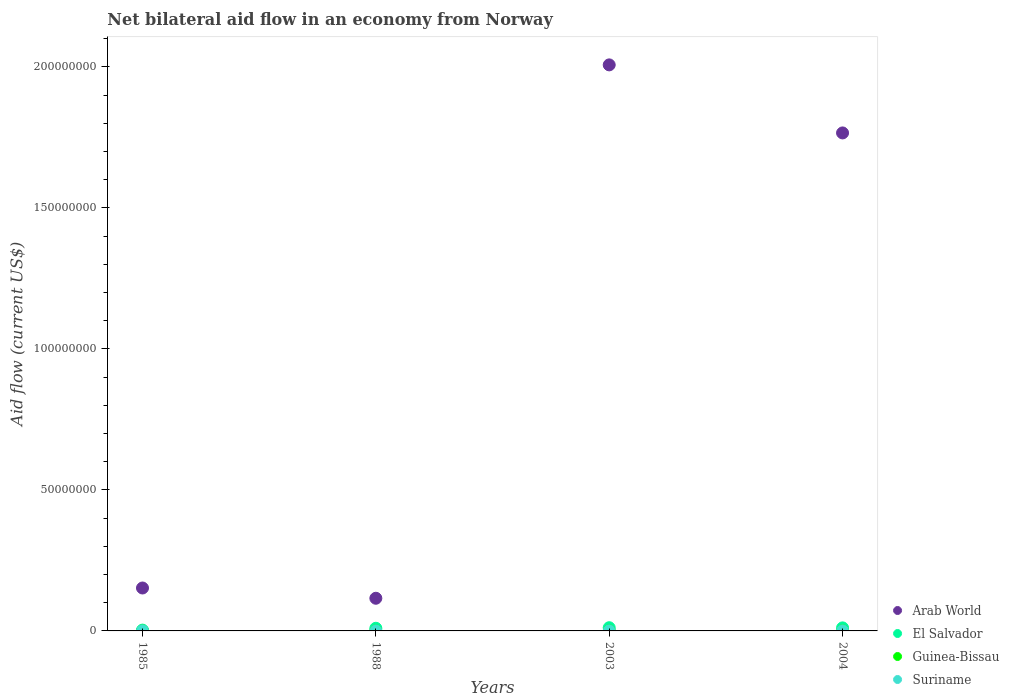What is the net bilateral aid flow in El Salvador in 2004?
Ensure brevity in your answer.  1.08e+06. Across all years, what is the maximum net bilateral aid flow in El Salvador?
Offer a terse response. 1.14e+06. Across all years, what is the minimum net bilateral aid flow in Suriname?
Offer a very short reply. 10000. What is the difference between the net bilateral aid flow in Guinea-Bissau in 1988 and the net bilateral aid flow in El Salvador in 2003?
Provide a short and direct response. -1.13e+06. What is the average net bilateral aid flow in Guinea-Bissau per year?
Your answer should be compact. 3.25e+04. In the year 1988, what is the difference between the net bilateral aid flow in Guinea-Bissau and net bilateral aid flow in El Salvador?
Provide a short and direct response. -9.30e+05. What is the ratio of the net bilateral aid flow in Guinea-Bissau in 1985 to that in 2004?
Offer a very short reply. 0.17. Is the difference between the net bilateral aid flow in Guinea-Bissau in 1985 and 2003 greater than the difference between the net bilateral aid flow in El Salvador in 1985 and 2003?
Offer a terse response. Yes. In how many years, is the net bilateral aid flow in Guinea-Bissau greater than the average net bilateral aid flow in Guinea-Bissau taken over all years?
Provide a succinct answer. 2. Is it the case that in every year, the sum of the net bilateral aid flow in Guinea-Bissau and net bilateral aid flow in El Salvador  is greater than the sum of net bilateral aid flow in Arab World and net bilateral aid flow in Suriname?
Provide a short and direct response. No. Does the net bilateral aid flow in Arab World monotonically increase over the years?
Keep it short and to the point. No. Is the net bilateral aid flow in Arab World strictly greater than the net bilateral aid flow in Suriname over the years?
Your answer should be very brief. Yes. Is the net bilateral aid flow in Guinea-Bissau strictly less than the net bilateral aid flow in Arab World over the years?
Your answer should be compact. Yes. Are the values on the major ticks of Y-axis written in scientific E-notation?
Ensure brevity in your answer.  No. How many legend labels are there?
Offer a terse response. 4. What is the title of the graph?
Give a very brief answer. Net bilateral aid flow in an economy from Norway. What is the Aid flow (current US$) of Arab World in 1985?
Offer a terse response. 1.52e+07. What is the Aid flow (current US$) in El Salvador in 1985?
Your response must be concise. 2.90e+05. What is the Aid flow (current US$) in Suriname in 1985?
Your answer should be compact. 10000. What is the Aid flow (current US$) in Arab World in 1988?
Your response must be concise. 1.16e+07. What is the Aid flow (current US$) in El Salvador in 1988?
Your response must be concise. 9.40e+05. What is the Aid flow (current US$) in Arab World in 2003?
Offer a terse response. 2.01e+08. What is the Aid flow (current US$) in El Salvador in 2003?
Your response must be concise. 1.14e+06. What is the Aid flow (current US$) of Guinea-Bissau in 2003?
Provide a succinct answer. 5.00e+04. What is the Aid flow (current US$) in Suriname in 2003?
Keep it short and to the point. 3.00e+04. What is the Aid flow (current US$) of Arab World in 2004?
Keep it short and to the point. 1.77e+08. What is the Aid flow (current US$) of El Salvador in 2004?
Keep it short and to the point. 1.08e+06. Across all years, what is the maximum Aid flow (current US$) in Arab World?
Provide a succinct answer. 2.01e+08. Across all years, what is the maximum Aid flow (current US$) in El Salvador?
Offer a very short reply. 1.14e+06. Across all years, what is the minimum Aid flow (current US$) of Arab World?
Ensure brevity in your answer.  1.16e+07. Across all years, what is the minimum Aid flow (current US$) in Guinea-Bissau?
Your answer should be compact. 10000. Across all years, what is the minimum Aid flow (current US$) in Suriname?
Your response must be concise. 10000. What is the total Aid flow (current US$) in Arab World in the graph?
Provide a succinct answer. 4.04e+08. What is the total Aid flow (current US$) in El Salvador in the graph?
Your answer should be very brief. 3.45e+06. What is the total Aid flow (current US$) of Guinea-Bissau in the graph?
Your answer should be very brief. 1.30e+05. What is the total Aid flow (current US$) in Suriname in the graph?
Your response must be concise. 8.00e+04. What is the difference between the Aid flow (current US$) of Arab World in 1985 and that in 1988?
Provide a short and direct response. 3.64e+06. What is the difference between the Aid flow (current US$) in El Salvador in 1985 and that in 1988?
Your response must be concise. -6.50e+05. What is the difference between the Aid flow (current US$) in Arab World in 1985 and that in 2003?
Ensure brevity in your answer.  -1.85e+08. What is the difference between the Aid flow (current US$) in El Salvador in 1985 and that in 2003?
Offer a terse response. -8.50e+05. What is the difference between the Aid flow (current US$) of Guinea-Bissau in 1985 and that in 2003?
Provide a short and direct response. -4.00e+04. What is the difference between the Aid flow (current US$) of Suriname in 1985 and that in 2003?
Give a very brief answer. -2.00e+04. What is the difference between the Aid flow (current US$) of Arab World in 1985 and that in 2004?
Your response must be concise. -1.61e+08. What is the difference between the Aid flow (current US$) of El Salvador in 1985 and that in 2004?
Give a very brief answer. -7.90e+05. What is the difference between the Aid flow (current US$) of Guinea-Bissau in 1985 and that in 2004?
Make the answer very short. -5.00e+04. What is the difference between the Aid flow (current US$) of Arab World in 1988 and that in 2003?
Make the answer very short. -1.89e+08. What is the difference between the Aid flow (current US$) in Arab World in 1988 and that in 2004?
Offer a terse response. -1.65e+08. What is the difference between the Aid flow (current US$) in Guinea-Bissau in 1988 and that in 2004?
Your answer should be very brief. -5.00e+04. What is the difference between the Aid flow (current US$) of Arab World in 2003 and that in 2004?
Your answer should be compact. 2.41e+07. What is the difference between the Aid flow (current US$) in Guinea-Bissau in 2003 and that in 2004?
Your response must be concise. -10000. What is the difference between the Aid flow (current US$) in Arab World in 1985 and the Aid flow (current US$) in El Salvador in 1988?
Offer a terse response. 1.43e+07. What is the difference between the Aid flow (current US$) of Arab World in 1985 and the Aid flow (current US$) of Guinea-Bissau in 1988?
Your response must be concise. 1.52e+07. What is the difference between the Aid flow (current US$) of Arab World in 1985 and the Aid flow (current US$) of Suriname in 1988?
Make the answer very short. 1.52e+07. What is the difference between the Aid flow (current US$) of El Salvador in 1985 and the Aid flow (current US$) of Guinea-Bissau in 1988?
Your response must be concise. 2.80e+05. What is the difference between the Aid flow (current US$) of Arab World in 1985 and the Aid flow (current US$) of El Salvador in 2003?
Provide a short and direct response. 1.41e+07. What is the difference between the Aid flow (current US$) of Arab World in 1985 and the Aid flow (current US$) of Guinea-Bissau in 2003?
Provide a succinct answer. 1.52e+07. What is the difference between the Aid flow (current US$) of Arab World in 1985 and the Aid flow (current US$) of Suriname in 2003?
Your answer should be compact. 1.52e+07. What is the difference between the Aid flow (current US$) in El Salvador in 1985 and the Aid flow (current US$) in Guinea-Bissau in 2003?
Your response must be concise. 2.40e+05. What is the difference between the Aid flow (current US$) in Guinea-Bissau in 1985 and the Aid flow (current US$) in Suriname in 2003?
Ensure brevity in your answer.  -2.00e+04. What is the difference between the Aid flow (current US$) in Arab World in 1985 and the Aid flow (current US$) in El Salvador in 2004?
Your response must be concise. 1.41e+07. What is the difference between the Aid flow (current US$) in Arab World in 1985 and the Aid flow (current US$) in Guinea-Bissau in 2004?
Keep it short and to the point. 1.52e+07. What is the difference between the Aid flow (current US$) of Arab World in 1985 and the Aid flow (current US$) of Suriname in 2004?
Offer a very short reply. 1.52e+07. What is the difference between the Aid flow (current US$) of El Salvador in 1985 and the Aid flow (current US$) of Guinea-Bissau in 2004?
Ensure brevity in your answer.  2.30e+05. What is the difference between the Aid flow (current US$) in Arab World in 1988 and the Aid flow (current US$) in El Salvador in 2003?
Make the answer very short. 1.04e+07. What is the difference between the Aid flow (current US$) of Arab World in 1988 and the Aid flow (current US$) of Guinea-Bissau in 2003?
Your answer should be very brief. 1.15e+07. What is the difference between the Aid flow (current US$) in Arab World in 1988 and the Aid flow (current US$) in Suriname in 2003?
Provide a succinct answer. 1.16e+07. What is the difference between the Aid flow (current US$) in El Salvador in 1988 and the Aid flow (current US$) in Guinea-Bissau in 2003?
Keep it short and to the point. 8.90e+05. What is the difference between the Aid flow (current US$) of El Salvador in 1988 and the Aid flow (current US$) of Suriname in 2003?
Make the answer very short. 9.10e+05. What is the difference between the Aid flow (current US$) in Guinea-Bissau in 1988 and the Aid flow (current US$) in Suriname in 2003?
Make the answer very short. -2.00e+04. What is the difference between the Aid flow (current US$) in Arab World in 1988 and the Aid flow (current US$) in El Salvador in 2004?
Make the answer very short. 1.05e+07. What is the difference between the Aid flow (current US$) of Arab World in 1988 and the Aid flow (current US$) of Guinea-Bissau in 2004?
Offer a very short reply. 1.15e+07. What is the difference between the Aid flow (current US$) in Arab World in 1988 and the Aid flow (current US$) in Suriname in 2004?
Keep it short and to the point. 1.16e+07. What is the difference between the Aid flow (current US$) in El Salvador in 1988 and the Aid flow (current US$) in Guinea-Bissau in 2004?
Make the answer very short. 8.80e+05. What is the difference between the Aid flow (current US$) in El Salvador in 1988 and the Aid flow (current US$) in Suriname in 2004?
Make the answer very short. 9.10e+05. What is the difference between the Aid flow (current US$) in Guinea-Bissau in 1988 and the Aid flow (current US$) in Suriname in 2004?
Provide a succinct answer. -2.00e+04. What is the difference between the Aid flow (current US$) in Arab World in 2003 and the Aid flow (current US$) in El Salvador in 2004?
Provide a short and direct response. 2.00e+08. What is the difference between the Aid flow (current US$) of Arab World in 2003 and the Aid flow (current US$) of Guinea-Bissau in 2004?
Give a very brief answer. 2.01e+08. What is the difference between the Aid flow (current US$) in Arab World in 2003 and the Aid flow (current US$) in Suriname in 2004?
Offer a very short reply. 2.01e+08. What is the difference between the Aid flow (current US$) in El Salvador in 2003 and the Aid flow (current US$) in Guinea-Bissau in 2004?
Offer a very short reply. 1.08e+06. What is the difference between the Aid flow (current US$) of El Salvador in 2003 and the Aid flow (current US$) of Suriname in 2004?
Offer a very short reply. 1.11e+06. What is the difference between the Aid flow (current US$) of Guinea-Bissau in 2003 and the Aid flow (current US$) of Suriname in 2004?
Keep it short and to the point. 2.00e+04. What is the average Aid flow (current US$) of Arab World per year?
Give a very brief answer. 1.01e+08. What is the average Aid flow (current US$) of El Salvador per year?
Your answer should be very brief. 8.62e+05. What is the average Aid flow (current US$) in Guinea-Bissau per year?
Keep it short and to the point. 3.25e+04. What is the average Aid flow (current US$) of Suriname per year?
Ensure brevity in your answer.  2.00e+04. In the year 1985, what is the difference between the Aid flow (current US$) in Arab World and Aid flow (current US$) in El Salvador?
Your response must be concise. 1.49e+07. In the year 1985, what is the difference between the Aid flow (current US$) in Arab World and Aid flow (current US$) in Guinea-Bissau?
Your response must be concise. 1.52e+07. In the year 1985, what is the difference between the Aid flow (current US$) of Arab World and Aid flow (current US$) of Suriname?
Provide a short and direct response. 1.52e+07. In the year 1985, what is the difference between the Aid flow (current US$) in El Salvador and Aid flow (current US$) in Suriname?
Provide a short and direct response. 2.80e+05. In the year 1988, what is the difference between the Aid flow (current US$) in Arab World and Aid flow (current US$) in El Salvador?
Make the answer very short. 1.06e+07. In the year 1988, what is the difference between the Aid flow (current US$) of Arab World and Aid flow (current US$) of Guinea-Bissau?
Ensure brevity in your answer.  1.16e+07. In the year 1988, what is the difference between the Aid flow (current US$) of Arab World and Aid flow (current US$) of Suriname?
Offer a terse response. 1.16e+07. In the year 1988, what is the difference between the Aid flow (current US$) of El Salvador and Aid flow (current US$) of Guinea-Bissau?
Provide a succinct answer. 9.30e+05. In the year 1988, what is the difference between the Aid flow (current US$) of El Salvador and Aid flow (current US$) of Suriname?
Your response must be concise. 9.30e+05. In the year 2003, what is the difference between the Aid flow (current US$) in Arab World and Aid flow (current US$) in El Salvador?
Offer a very short reply. 2.00e+08. In the year 2003, what is the difference between the Aid flow (current US$) of Arab World and Aid flow (current US$) of Guinea-Bissau?
Provide a succinct answer. 2.01e+08. In the year 2003, what is the difference between the Aid flow (current US$) of Arab World and Aid flow (current US$) of Suriname?
Provide a succinct answer. 2.01e+08. In the year 2003, what is the difference between the Aid flow (current US$) of El Salvador and Aid flow (current US$) of Guinea-Bissau?
Your answer should be compact. 1.09e+06. In the year 2003, what is the difference between the Aid flow (current US$) of El Salvador and Aid flow (current US$) of Suriname?
Keep it short and to the point. 1.11e+06. In the year 2004, what is the difference between the Aid flow (current US$) in Arab World and Aid flow (current US$) in El Salvador?
Ensure brevity in your answer.  1.76e+08. In the year 2004, what is the difference between the Aid flow (current US$) in Arab World and Aid flow (current US$) in Guinea-Bissau?
Offer a very short reply. 1.77e+08. In the year 2004, what is the difference between the Aid flow (current US$) of Arab World and Aid flow (current US$) of Suriname?
Offer a very short reply. 1.77e+08. In the year 2004, what is the difference between the Aid flow (current US$) in El Salvador and Aid flow (current US$) in Guinea-Bissau?
Your response must be concise. 1.02e+06. In the year 2004, what is the difference between the Aid flow (current US$) of El Salvador and Aid flow (current US$) of Suriname?
Keep it short and to the point. 1.05e+06. In the year 2004, what is the difference between the Aid flow (current US$) in Guinea-Bissau and Aid flow (current US$) in Suriname?
Offer a terse response. 3.00e+04. What is the ratio of the Aid flow (current US$) of Arab World in 1985 to that in 1988?
Provide a short and direct response. 1.31. What is the ratio of the Aid flow (current US$) in El Salvador in 1985 to that in 1988?
Your answer should be compact. 0.31. What is the ratio of the Aid flow (current US$) of Guinea-Bissau in 1985 to that in 1988?
Provide a succinct answer. 1. What is the ratio of the Aid flow (current US$) in Suriname in 1985 to that in 1988?
Give a very brief answer. 1. What is the ratio of the Aid flow (current US$) of Arab World in 1985 to that in 2003?
Offer a very short reply. 0.08. What is the ratio of the Aid flow (current US$) of El Salvador in 1985 to that in 2003?
Provide a succinct answer. 0.25. What is the ratio of the Aid flow (current US$) in Arab World in 1985 to that in 2004?
Keep it short and to the point. 0.09. What is the ratio of the Aid flow (current US$) of El Salvador in 1985 to that in 2004?
Your answer should be very brief. 0.27. What is the ratio of the Aid flow (current US$) in Arab World in 1988 to that in 2003?
Keep it short and to the point. 0.06. What is the ratio of the Aid flow (current US$) in El Salvador in 1988 to that in 2003?
Ensure brevity in your answer.  0.82. What is the ratio of the Aid flow (current US$) in Guinea-Bissau in 1988 to that in 2003?
Keep it short and to the point. 0.2. What is the ratio of the Aid flow (current US$) of Suriname in 1988 to that in 2003?
Your answer should be compact. 0.33. What is the ratio of the Aid flow (current US$) of Arab World in 1988 to that in 2004?
Your answer should be very brief. 0.07. What is the ratio of the Aid flow (current US$) of El Salvador in 1988 to that in 2004?
Ensure brevity in your answer.  0.87. What is the ratio of the Aid flow (current US$) in Suriname in 1988 to that in 2004?
Provide a short and direct response. 0.33. What is the ratio of the Aid flow (current US$) of Arab World in 2003 to that in 2004?
Ensure brevity in your answer.  1.14. What is the ratio of the Aid flow (current US$) in El Salvador in 2003 to that in 2004?
Provide a succinct answer. 1.06. What is the ratio of the Aid flow (current US$) of Suriname in 2003 to that in 2004?
Give a very brief answer. 1. What is the difference between the highest and the second highest Aid flow (current US$) of Arab World?
Offer a terse response. 2.41e+07. What is the difference between the highest and the second highest Aid flow (current US$) in Guinea-Bissau?
Offer a very short reply. 10000. What is the difference between the highest and the second highest Aid flow (current US$) of Suriname?
Provide a short and direct response. 0. What is the difference between the highest and the lowest Aid flow (current US$) of Arab World?
Provide a succinct answer. 1.89e+08. What is the difference between the highest and the lowest Aid flow (current US$) in El Salvador?
Give a very brief answer. 8.50e+05. What is the difference between the highest and the lowest Aid flow (current US$) of Guinea-Bissau?
Provide a short and direct response. 5.00e+04. 